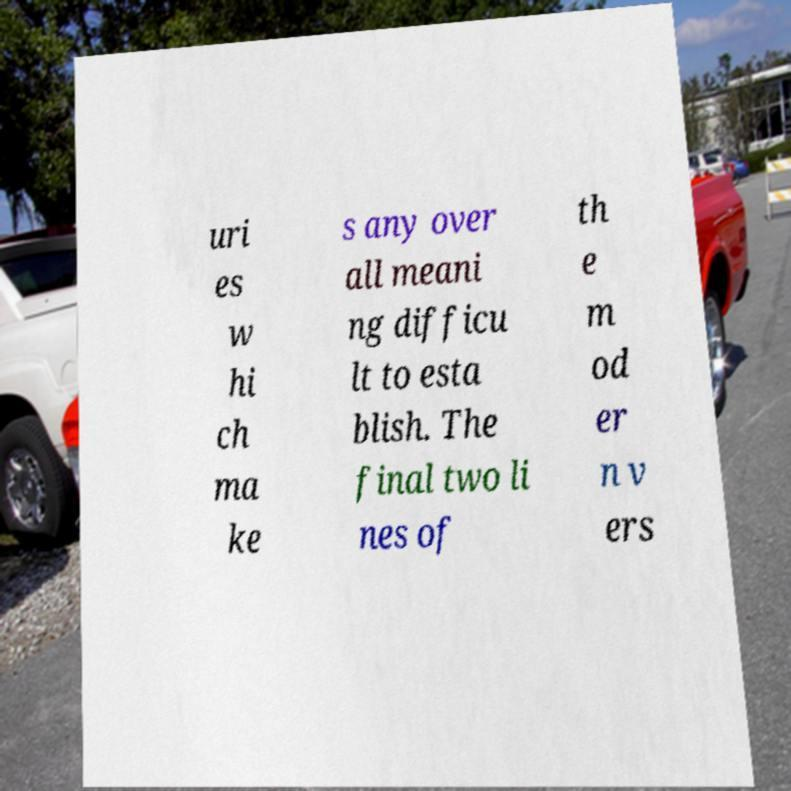Can you read and provide the text displayed in the image?This photo seems to have some interesting text. Can you extract and type it out for me? uri es w hi ch ma ke s any over all meani ng difficu lt to esta blish. The final two li nes of th e m od er n v ers 